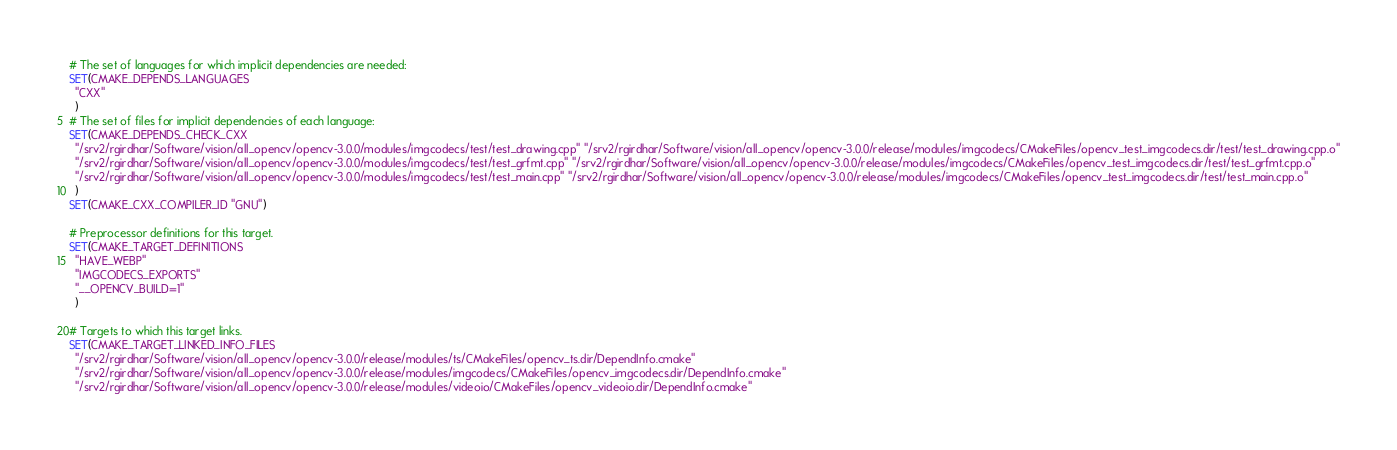Convert code to text. <code><loc_0><loc_0><loc_500><loc_500><_CMake_># The set of languages for which implicit dependencies are needed:
SET(CMAKE_DEPENDS_LANGUAGES
  "CXX"
  )
# The set of files for implicit dependencies of each language:
SET(CMAKE_DEPENDS_CHECK_CXX
  "/srv2/rgirdhar/Software/vision/all_opencv/opencv-3.0.0/modules/imgcodecs/test/test_drawing.cpp" "/srv2/rgirdhar/Software/vision/all_opencv/opencv-3.0.0/release/modules/imgcodecs/CMakeFiles/opencv_test_imgcodecs.dir/test/test_drawing.cpp.o"
  "/srv2/rgirdhar/Software/vision/all_opencv/opencv-3.0.0/modules/imgcodecs/test/test_grfmt.cpp" "/srv2/rgirdhar/Software/vision/all_opencv/opencv-3.0.0/release/modules/imgcodecs/CMakeFiles/opencv_test_imgcodecs.dir/test/test_grfmt.cpp.o"
  "/srv2/rgirdhar/Software/vision/all_opencv/opencv-3.0.0/modules/imgcodecs/test/test_main.cpp" "/srv2/rgirdhar/Software/vision/all_opencv/opencv-3.0.0/release/modules/imgcodecs/CMakeFiles/opencv_test_imgcodecs.dir/test/test_main.cpp.o"
  )
SET(CMAKE_CXX_COMPILER_ID "GNU")

# Preprocessor definitions for this target.
SET(CMAKE_TARGET_DEFINITIONS
  "HAVE_WEBP"
  "IMGCODECS_EXPORTS"
  "__OPENCV_BUILD=1"
  )

# Targets to which this target links.
SET(CMAKE_TARGET_LINKED_INFO_FILES
  "/srv2/rgirdhar/Software/vision/all_opencv/opencv-3.0.0/release/modules/ts/CMakeFiles/opencv_ts.dir/DependInfo.cmake"
  "/srv2/rgirdhar/Software/vision/all_opencv/opencv-3.0.0/release/modules/imgcodecs/CMakeFiles/opencv_imgcodecs.dir/DependInfo.cmake"
  "/srv2/rgirdhar/Software/vision/all_opencv/opencv-3.0.0/release/modules/videoio/CMakeFiles/opencv_videoio.dir/DependInfo.cmake"</code> 